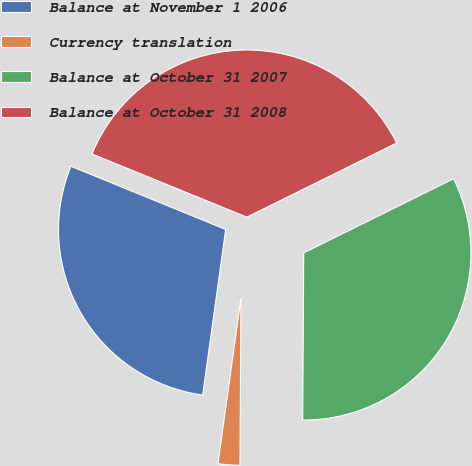Convert chart. <chart><loc_0><loc_0><loc_500><loc_500><pie_chart><fcel>Balance at November 1 2006<fcel>Currency translation<fcel>Balance at October 31 2007<fcel>Balance at October 31 2008<nl><fcel>28.97%<fcel>2.1%<fcel>32.41%<fcel>36.52%<nl></chart> 